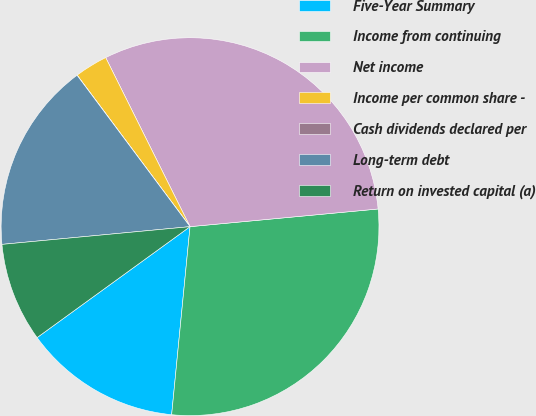Convert chart to OTSL. <chart><loc_0><loc_0><loc_500><loc_500><pie_chart><fcel>Five-Year Summary<fcel>Income from continuing<fcel>Net income<fcel>Income per common share -<fcel>Cash dividends declared per<fcel>Long-term debt<fcel>Return on invested capital (a)<nl><fcel>13.46%<fcel>28.04%<fcel>30.87%<fcel>2.83%<fcel>0.01%<fcel>16.29%<fcel>8.49%<nl></chart> 